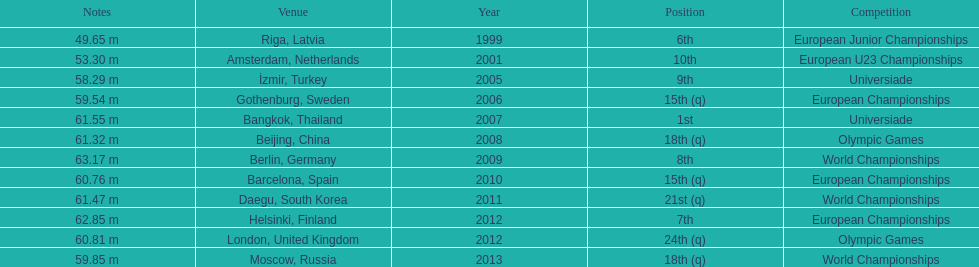What was the last competition he was in before the 2012 olympics? European Championships. 